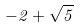<formula> <loc_0><loc_0><loc_500><loc_500>- 2 + \sqrt { 5 }</formula> 